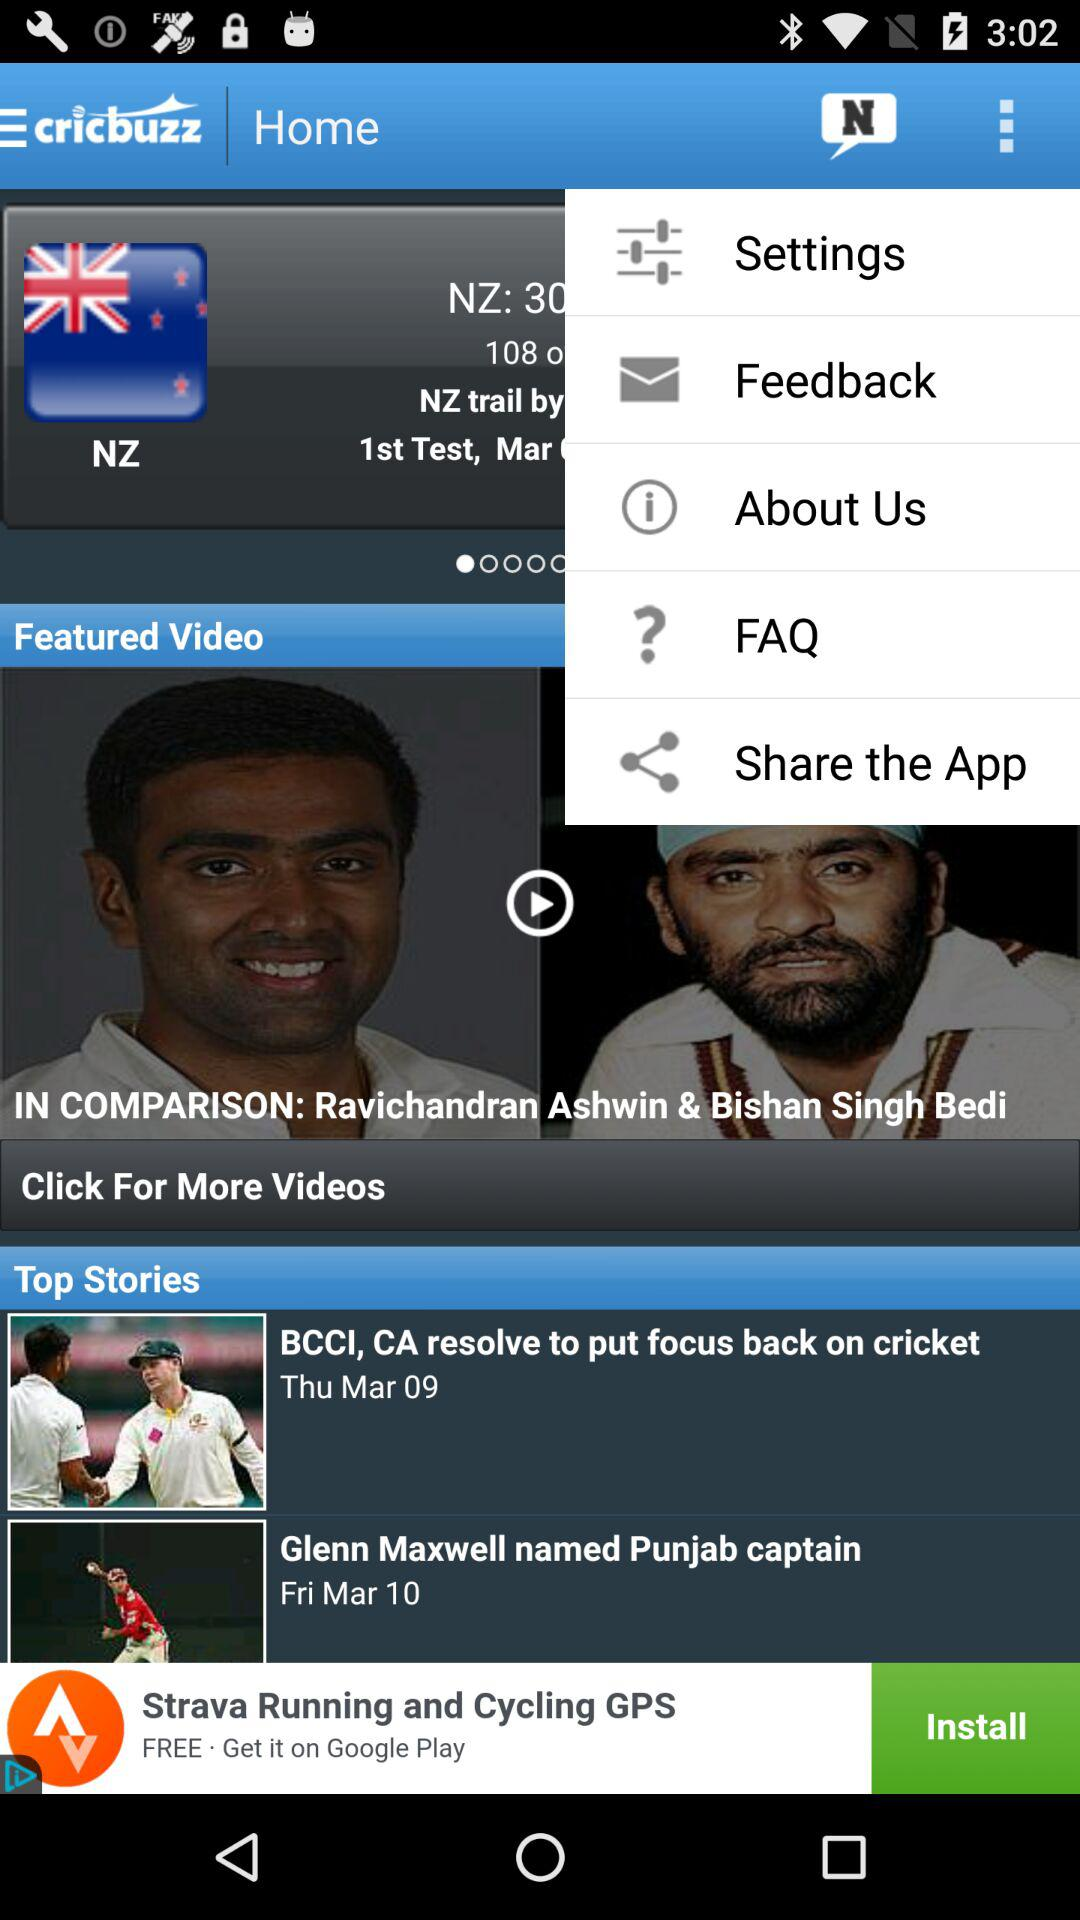What is the application name? The application name is "cricbuzz". 